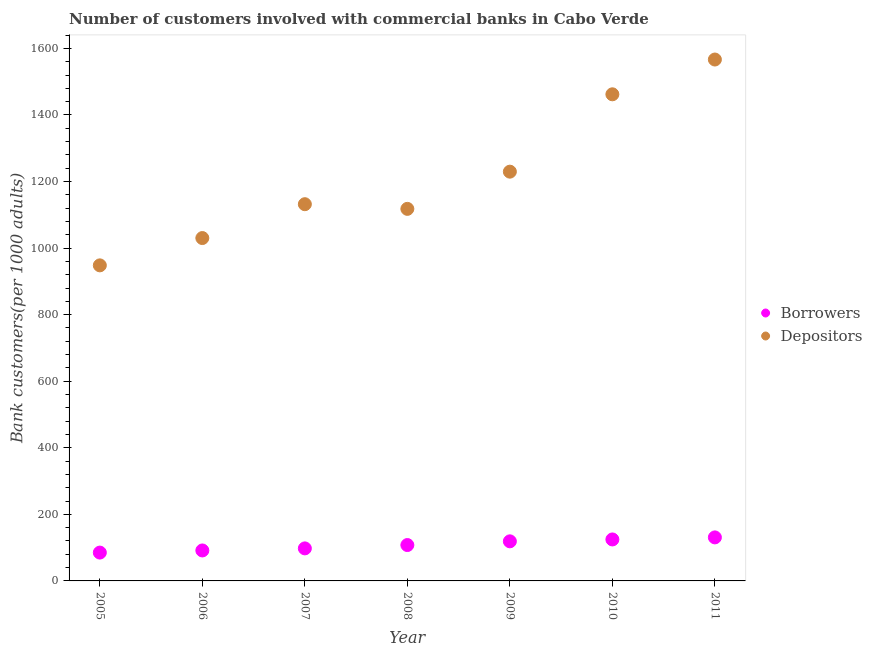How many different coloured dotlines are there?
Give a very brief answer. 2. Is the number of dotlines equal to the number of legend labels?
Offer a terse response. Yes. What is the number of depositors in 2007?
Keep it short and to the point. 1131.93. Across all years, what is the maximum number of depositors?
Your response must be concise. 1566.62. Across all years, what is the minimum number of borrowers?
Provide a short and direct response. 85.13. In which year was the number of depositors minimum?
Make the answer very short. 2005. What is the total number of depositors in the graph?
Your answer should be very brief. 8486.64. What is the difference between the number of borrowers in 2007 and that in 2010?
Make the answer very short. -26.86. What is the difference between the number of depositors in 2007 and the number of borrowers in 2009?
Your response must be concise. 1012.97. What is the average number of depositors per year?
Provide a succinct answer. 1212.38. In the year 2008, what is the difference between the number of depositors and number of borrowers?
Your response must be concise. 1010.12. In how many years, is the number of borrowers greater than 360?
Keep it short and to the point. 0. What is the ratio of the number of borrowers in 2005 to that in 2010?
Provide a short and direct response. 0.68. Is the number of borrowers in 2006 less than that in 2007?
Ensure brevity in your answer.  Yes. Is the difference between the number of borrowers in 2008 and 2009 greater than the difference between the number of depositors in 2008 and 2009?
Offer a very short reply. Yes. What is the difference between the highest and the second highest number of depositors?
Your answer should be very brief. 104.49. What is the difference between the highest and the lowest number of depositors?
Offer a terse response. 618.47. In how many years, is the number of borrowers greater than the average number of borrowers taken over all years?
Your answer should be very brief. 3. Is the number of depositors strictly less than the number of borrowers over the years?
Your answer should be very brief. No. What is the difference between two consecutive major ticks on the Y-axis?
Your response must be concise. 200. Where does the legend appear in the graph?
Provide a succinct answer. Center right. How are the legend labels stacked?
Make the answer very short. Vertical. What is the title of the graph?
Offer a very short reply. Number of customers involved with commercial banks in Cabo Verde. Does "National Tourists" appear as one of the legend labels in the graph?
Keep it short and to the point. No. What is the label or title of the Y-axis?
Offer a very short reply. Bank customers(per 1000 adults). What is the Bank customers(per 1000 adults) in Borrowers in 2005?
Your response must be concise. 85.13. What is the Bank customers(per 1000 adults) in Depositors in 2005?
Provide a short and direct response. 948.15. What is the Bank customers(per 1000 adults) in Borrowers in 2006?
Provide a succinct answer. 91.53. What is the Bank customers(per 1000 adults) in Depositors in 2006?
Offer a very short reply. 1030.2. What is the Bank customers(per 1000 adults) of Borrowers in 2007?
Keep it short and to the point. 97.75. What is the Bank customers(per 1000 adults) in Depositors in 2007?
Provide a short and direct response. 1131.93. What is the Bank customers(per 1000 adults) in Borrowers in 2008?
Your response must be concise. 107.79. What is the Bank customers(per 1000 adults) of Depositors in 2008?
Offer a very short reply. 1117.91. What is the Bank customers(per 1000 adults) in Borrowers in 2009?
Give a very brief answer. 118.96. What is the Bank customers(per 1000 adults) in Depositors in 2009?
Your response must be concise. 1229.69. What is the Bank customers(per 1000 adults) of Borrowers in 2010?
Your answer should be compact. 124.61. What is the Bank customers(per 1000 adults) in Depositors in 2010?
Your answer should be very brief. 1462.14. What is the Bank customers(per 1000 adults) of Borrowers in 2011?
Your answer should be very brief. 130.78. What is the Bank customers(per 1000 adults) of Depositors in 2011?
Give a very brief answer. 1566.62. Across all years, what is the maximum Bank customers(per 1000 adults) in Borrowers?
Provide a short and direct response. 130.78. Across all years, what is the maximum Bank customers(per 1000 adults) of Depositors?
Keep it short and to the point. 1566.62. Across all years, what is the minimum Bank customers(per 1000 adults) in Borrowers?
Give a very brief answer. 85.13. Across all years, what is the minimum Bank customers(per 1000 adults) of Depositors?
Your answer should be very brief. 948.15. What is the total Bank customers(per 1000 adults) in Borrowers in the graph?
Make the answer very short. 756.56. What is the total Bank customers(per 1000 adults) in Depositors in the graph?
Your response must be concise. 8486.64. What is the difference between the Bank customers(per 1000 adults) of Borrowers in 2005 and that in 2006?
Ensure brevity in your answer.  -6.4. What is the difference between the Bank customers(per 1000 adults) in Depositors in 2005 and that in 2006?
Provide a short and direct response. -82.05. What is the difference between the Bank customers(per 1000 adults) of Borrowers in 2005 and that in 2007?
Provide a succinct answer. -12.62. What is the difference between the Bank customers(per 1000 adults) in Depositors in 2005 and that in 2007?
Give a very brief answer. -183.78. What is the difference between the Bank customers(per 1000 adults) in Borrowers in 2005 and that in 2008?
Your response must be concise. -22.66. What is the difference between the Bank customers(per 1000 adults) of Depositors in 2005 and that in 2008?
Offer a terse response. -169.76. What is the difference between the Bank customers(per 1000 adults) in Borrowers in 2005 and that in 2009?
Provide a succinct answer. -33.83. What is the difference between the Bank customers(per 1000 adults) of Depositors in 2005 and that in 2009?
Offer a very short reply. -281.53. What is the difference between the Bank customers(per 1000 adults) of Borrowers in 2005 and that in 2010?
Your answer should be compact. -39.48. What is the difference between the Bank customers(per 1000 adults) of Depositors in 2005 and that in 2010?
Provide a short and direct response. -513.98. What is the difference between the Bank customers(per 1000 adults) of Borrowers in 2005 and that in 2011?
Make the answer very short. -45.65. What is the difference between the Bank customers(per 1000 adults) in Depositors in 2005 and that in 2011?
Keep it short and to the point. -618.47. What is the difference between the Bank customers(per 1000 adults) in Borrowers in 2006 and that in 2007?
Offer a terse response. -6.22. What is the difference between the Bank customers(per 1000 adults) of Depositors in 2006 and that in 2007?
Offer a terse response. -101.73. What is the difference between the Bank customers(per 1000 adults) of Borrowers in 2006 and that in 2008?
Offer a very short reply. -16.26. What is the difference between the Bank customers(per 1000 adults) of Depositors in 2006 and that in 2008?
Your answer should be very brief. -87.71. What is the difference between the Bank customers(per 1000 adults) in Borrowers in 2006 and that in 2009?
Give a very brief answer. -27.42. What is the difference between the Bank customers(per 1000 adults) in Depositors in 2006 and that in 2009?
Your response must be concise. -199.48. What is the difference between the Bank customers(per 1000 adults) in Borrowers in 2006 and that in 2010?
Provide a short and direct response. -33.07. What is the difference between the Bank customers(per 1000 adults) in Depositors in 2006 and that in 2010?
Your answer should be compact. -431.93. What is the difference between the Bank customers(per 1000 adults) of Borrowers in 2006 and that in 2011?
Give a very brief answer. -39.25. What is the difference between the Bank customers(per 1000 adults) of Depositors in 2006 and that in 2011?
Provide a succinct answer. -536.42. What is the difference between the Bank customers(per 1000 adults) in Borrowers in 2007 and that in 2008?
Make the answer very short. -10.04. What is the difference between the Bank customers(per 1000 adults) in Depositors in 2007 and that in 2008?
Give a very brief answer. 14.02. What is the difference between the Bank customers(per 1000 adults) of Borrowers in 2007 and that in 2009?
Offer a very short reply. -21.21. What is the difference between the Bank customers(per 1000 adults) in Depositors in 2007 and that in 2009?
Your answer should be compact. -97.75. What is the difference between the Bank customers(per 1000 adults) of Borrowers in 2007 and that in 2010?
Provide a succinct answer. -26.86. What is the difference between the Bank customers(per 1000 adults) in Depositors in 2007 and that in 2010?
Ensure brevity in your answer.  -330.2. What is the difference between the Bank customers(per 1000 adults) of Borrowers in 2007 and that in 2011?
Provide a short and direct response. -33.03. What is the difference between the Bank customers(per 1000 adults) in Depositors in 2007 and that in 2011?
Make the answer very short. -434.69. What is the difference between the Bank customers(per 1000 adults) in Borrowers in 2008 and that in 2009?
Give a very brief answer. -11.16. What is the difference between the Bank customers(per 1000 adults) of Depositors in 2008 and that in 2009?
Offer a terse response. -111.77. What is the difference between the Bank customers(per 1000 adults) in Borrowers in 2008 and that in 2010?
Provide a succinct answer. -16.81. What is the difference between the Bank customers(per 1000 adults) in Depositors in 2008 and that in 2010?
Offer a terse response. -344.22. What is the difference between the Bank customers(per 1000 adults) of Borrowers in 2008 and that in 2011?
Keep it short and to the point. -22.99. What is the difference between the Bank customers(per 1000 adults) of Depositors in 2008 and that in 2011?
Offer a terse response. -448.71. What is the difference between the Bank customers(per 1000 adults) of Borrowers in 2009 and that in 2010?
Keep it short and to the point. -5.65. What is the difference between the Bank customers(per 1000 adults) in Depositors in 2009 and that in 2010?
Give a very brief answer. -232.45. What is the difference between the Bank customers(per 1000 adults) in Borrowers in 2009 and that in 2011?
Offer a very short reply. -11.82. What is the difference between the Bank customers(per 1000 adults) of Depositors in 2009 and that in 2011?
Your response must be concise. -336.94. What is the difference between the Bank customers(per 1000 adults) of Borrowers in 2010 and that in 2011?
Keep it short and to the point. -6.18. What is the difference between the Bank customers(per 1000 adults) of Depositors in 2010 and that in 2011?
Provide a short and direct response. -104.49. What is the difference between the Bank customers(per 1000 adults) of Borrowers in 2005 and the Bank customers(per 1000 adults) of Depositors in 2006?
Provide a succinct answer. -945.07. What is the difference between the Bank customers(per 1000 adults) in Borrowers in 2005 and the Bank customers(per 1000 adults) in Depositors in 2007?
Offer a very short reply. -1046.8. What is the difference between the Bank customers(per 1000 adults) of Borrowers in 2005 and the Bank customers(per 1000 adults) of Depositors in 2008?
Ensure brevity in your answer.  -1032.78. What is the difference between the Bank customers(per 1000 adults) in Borrowers in 2005 and the Bank customers(per 1000 adults) in Depositors in 2009?
Keep it short and to the point. -1144.55. What is the difference between the Bank customers(per 1000 adults) in Borrowers in 2005 and the Bank customers(per 1000 adults) in Depositors in 2010?
Offer a very short reply. -1377. What is the difference between the Bank customers(per 1000 adults) in Borrowers in 2005 and the Bank customers(per 1000 adults) in Depositors in 2011?
Offer a terse response. -1481.49. What is the difference between the Bank customers(per 1000 adults) of Borrowers in 2006 and the Bank customers(per 1000 adults) of Depositors in 2007?
Make the answer very short. -1040.4. What is the difference between the Bank customers(per 1000 adults) of Borrowers in 2006 and the Bank customers(per 1000 adults) of Depositors in 2008?
Ensure brevity in your answer.  -1026.38. What is the difference between the Bank customers(per 1000 adults) of Borrowers in 2006 and the Bank customers(per 1000 adults) of Depositors in 2009?
Offer a very short reply. -1138.15. What is the difference between the Bank customers(per 1000 adults) of Borrowers in 2006 and the Bank customers(per 1000 adults) of Depositors in 2010?
Ensure brevity in your answer.  -1370.6. What is the difference between the Bank customers(per 1000 adults) in Borrowers in 2006 and the Bank customers(per 1000 adults) in Depositors in 2011?
Your answer should be compact. -1475.09. What is the difference between the Bank customers(per 1000 adults) of Borrowers in 2007 and the Bank customers(per 1000 adults) of Depositors in 2008?
Keep it short and to the point. -1020.16. What is the difference between the Bank customers(per 1000 adults) in Borrowers in 2007 and the Bank customers(per 1000 adults) in Depositors in 2009?
Your answer should be very brief. -1131.93. What is the difference between the Bank customers(per 1000 adults) in Borrowers in 2007 and the Bank customers(per 1000 adults) in Depositors in 2010?
Offer a very short reply. -1364.38. What is the difference between the Bank customers(per 1000 adults) in Borrowers in 2007 and the Bank customers(per 1000 adults) in Depositors in 2011?
Keep it short and to the point. -1468.87. What is the difference between the Bank customers(per 1000 adults) in Borrowers in 2008 and the Bank customers(per 1000 adults) in Depositors in 2009?
Offer a very short reply. -1121.89. What is the difference between the Bank customers(per 1000 adults) in Borrowers in 2008 and the Bank customers(per 1000 adults) in Depositors in 2010?
Offer a very short reply. -1354.34. What is the difference between the Bank customers(per 1000 adults) of Borrowers in 2008 and the Bank customers(per 1000 adults) of Depositors in 2011?
Offer a terse response. -1458.83. What is the difference between the Bank customers(per 1000 adults) in Borrowers in 2009 and the Bank customers(per 1000 adults) in Depositors in 2010?
Ensure brevity in your answer.  -1343.18. What is the difference between the Bank customers(per 1000 adults) of Borrowers in 2009 and the Bank customers(per 1000 adults) of Depositors in 2011?
Keep it short and to the point. -1447.66. What is the difference between the Bank customers(per 1000 adults) of Borrowers in 2010 and the Bank customers(per 1000 adults) of Depositors in 2011?
Give a very brief answer. -1442.01. What is the average Bank customers(per 1000 adults) in Borrowers per year?
Offer a terse response. 108.08. What is the average Bank customers(per 1000 adults) of Depositors per year?
Your answer should be very brief. 1212.38. In the year 2005, what is the difference between the Bank customers(per 1000 adults) in Borrowers and Bank customers(per 1000 adults) in Depositors?
Your response must be concise. -863.02. In the year 2006, what is the difference between the Bank customers(per 1000 adults) of Borrowers and Bank customers(per 1000 adults) of Depositors?
Ensure brevity in your answer.  -938.67. In the year 2007, what is the difference between the Bank customers(per 1000 adults) in Borrowers and Bank customers(per 1000 adults) in Depositors?
Make the answer very short. -1034.18. In the year 2008, what is the difference between the Bank customers(per 1000 adults) of Borrowers and Bank customers(per 1000 adults) of Depositors?
Make the answer very short. -1010.12. In the year 2009, what is the difference between the Bank customers(per 1000 adults) of Borrowers and Bank customers(per 1000 adults) of Depositors?
Your answer should be compact. -1110.73. In the year 2010, what is the difference between the Bank customers(per 1000 adults) in Borrowers and Bank customers(per 1000 adults) in Depositors?
Ensure brevity in your answer.  -1337.53. In the year 2011, what is the difference between the Bank customers(per 1000 adults) in Borrowers and Bank customers(per 1000 adults) in Depositors?
Offer a terse response. -1435.84. What is the ratio of the Bank customers(per 1000 adults) of Borrowers in 2005 to that in 2006?
Keep it short and to the point. 0.93. What is the ratio of the Bank customers(per 1000 adults) in Depositors in 2005 to that in 2006?
Ensure brevity in your answer.  0.92. What is the ratio of the Bank customers(per 1000 adults) in Borrowers in 2005 to that in 2007?
Keep it short and to the point. 0.87. What is the ratio of the Bank customers(per 1000 adults) of Depositors in 2005 to that in 2007?
Give a very brief answer. 0.84. What is the ratio of the Bank customers(per 1000 adults) of Borrowers in 2005 to that in 2008?
Your answer should be very brief. 0.79. What is the ratio of the Bank customers(per 1000 adults) in Depositors in 2005 to that in 2008?
Give a very brief answer. 0.85. What is the ratio of the Bank customers(per 1000 adults) in Borrowers in 2005 to that in 2009?
Provide a short and direct response. 0.72. What is the ratio of the Bank customers(per 1000 adults) in Depositors in 2005 to that in 2009?
Keep it short and to the point. 0.77. What is the ratio of the Bank customers(per 1000 adults) of Borrowers in 2005 to that in 2010?
Make the answer very short. 0.68. What is the ratio of the Bank customers(per 1000 adults) of Depositors in 2005 to that in 2010?
Your answer should be very brief. 0.65. What is the ratio of the Bank customers(per 1000 adults) in Borrowers in 2005 to that in 2011?
Keep it short and to the point. 0.65. What is the ratio of the Bank customers(per 1000 adults) of Depositors in 2005 to that in 2011?
Give a very brief answer. 0.61. What is the ratio of the Bank customers(per 1000 adults) of Borrowers in 2006 to that in 2007?
Your response must be concise. 0.94. What is the ratio of the Bank customers(per 1000 adults) in Depositors in 2006 to that in 2007?
Your answer should be very brief. 0.91. What is the ratio of the Bank customers(per 1000 adults) of Borrowers in 2006 to that in 2008?
Your answer should be very brief. 0.85. What is the ratio of the Bank customers(per 1000 adults) in Depositors in 2006 to that in 2008?
Provide a short and direct response. 0.92. What is the ratio of the Bank customers(per 1000 adults) in Borrowers in 2006 to that in 2009?
Ensure brevity in your answer.  0.77. What is the ratio of the Bank customers(per 1000 adults) of Depositors in 2006 to that in 2009?
Ensure brevity in your answer.  0.84. What is the ratio of the Bank customers(per 1000 adults) of Borrowers in 2006 to that in 2010?
Your response must be concise. 0.73. What is the ratio of the Bank customers(per 1000 adults) in Depositors in 2006 to that in 2010?
Your answer should be very brief. 0.7. What is the ratio of the Bank customers(per 1000 adults) in Borrowers in 2006 to that in 2011?
Your response must be concise. 0.7. What is the ratio of the Bank customers(per 1000 adults) of Depositors in 2006 to that in 2011?
Your response must be concise. 0.66. What is the ratio of the Bank customers(per 1000 adults) in Borrowers in 2007 to that in 2008?
Provide a succinct answer. 0.91. What is the ratio of the Bank customers(per 1000 adults) in Depositors in 2007 to that in 2008?
Your answer should be compact. 1.01. What is the ratio of the Bank customers(per 1000 adults) of Borrowers in 2007 to that in 2009?
Ensure brevity in your answer.  0.82. What is the ratio of the Bank customers(per 1000 adults) of Depositors in 2007 to that in 2009?
Provide a short and direct response. 0.92. What is the ratio of the Bank customers(per 1000 adults) in Borrowers in 2007 to that in 2010?
Your answer should be very brief. 0.78. What is the ratio of the Bank customers(per 1000 adults) in Depositors in 2007 to that in 2010?
Make the answer very short. 0.77. What is the ratio of the Bank customers(per 1000 adults) of Borrowers in 2007 to that in 2011?
Offer a very short reply. 0.75. What is the ratio of the Bank customers(per 1000 adults) of Depositors in 2007 to that in 2011?
Offer a terse response. 0.72. What is the ratio of the Bank customers(per 1000 adults) of Borrowers in 2008 to that in 2009?
Your answer should be very brief. 0.91. What is the ratio of the Bank customers(per 1000 adults) of Depositors in 2008 to that in 2009?
Your response must be concise. 0.91. What is the ratio of the Bank customers(per 1000 adults) in Borrowers in 2008 to that in 2010?
Keep it short and to the point. 0.87. What is the ratio of the Bank customers(per 1000 adults) of Depositors in 2008 to that in 2010?
Your answer should be very brief. 0.76. What is the ratio of the Bank customers(per 1000 adults) in Borrowers in 2008 to that in 2011?
Provide a short and direct response. 0.82. What is the ratio of the Bank customers(per 1000 adults) of Depositors in 2008 to that in 2011?
Your response must be concise. 0.71. What is the ratio of the Bank customers(per 1000 adults) in Borrowers in 2009 to that in 2010?
Give a very brief answer. 0.95. What is the ratio of the Bank customers(per 1000 adults) in Depositors in 2009 to that in 2010?
Offer a very short reply. 0.84. What is the ratio of the Bank customers(per 1000 adults) in Borrowers in 2009 to that in 2011?
Give a very brief answer. 0.91. What is the ratio of the Bank customers(per 1000 adults) in Depositors in 2009 to that in 2011?
Ensure brevity in your answer.  0.78. What is the ratio of the Bank customers(per 1000 adults) in Borrowers in 2010 to that in 2011?
Your answer should be compact. 0.95. What is the difference between the highest and the second highest Bank customers(per 1000 adults) of Borrowers?
Offer a very short reply. 6.18. What is the difference between the highest and the second highest Bank customers(per 1000 adults) in Depositors?
Offer a very short reply. 104.49. What is the difference between the highest and the lowest Bank customers(per 1000 adults) of Borrowers?
Your answer should be compact. 45.65. What is the difference between the highest and the lowest Bank customers(per 1000 adults) in Depositors?
Your answer should be compact. 618.47. 